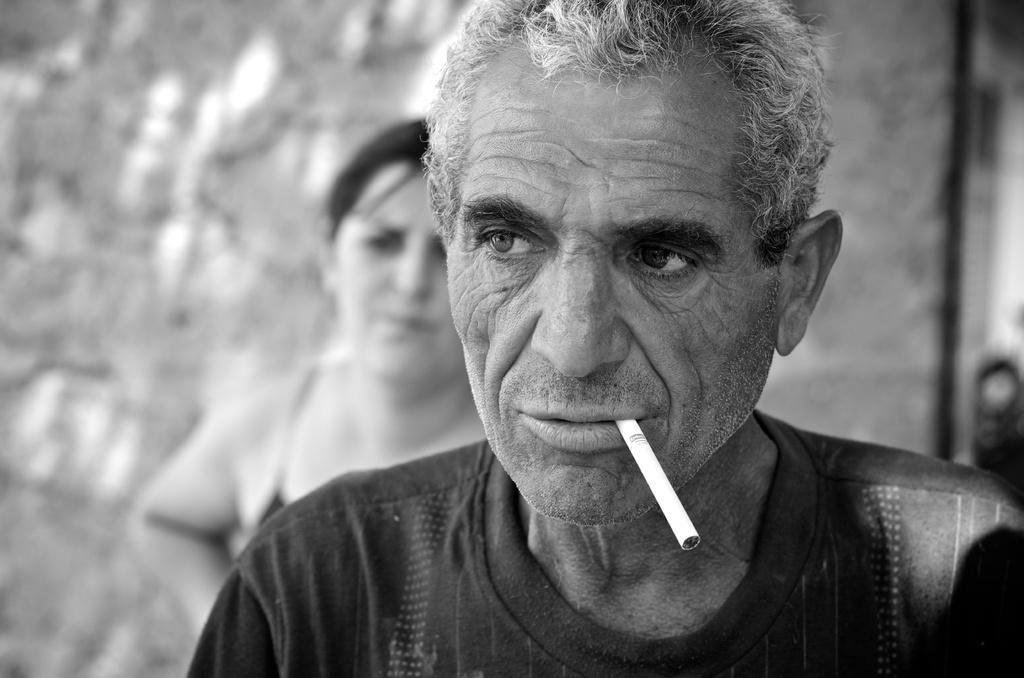Who is present in the image? There is a man and a woman in the image. What is the man wearing? The man is wearing a black t-shirt. What is the man holding or doing in the image? The man has a cigarette in his mouth. What type of church can be seen in the background of the image? There is no church visible in the image; it only features a man and a woman. How many planes are flying in the sky in the image? There are no planes visible in the image; it only features a man and a woman. 